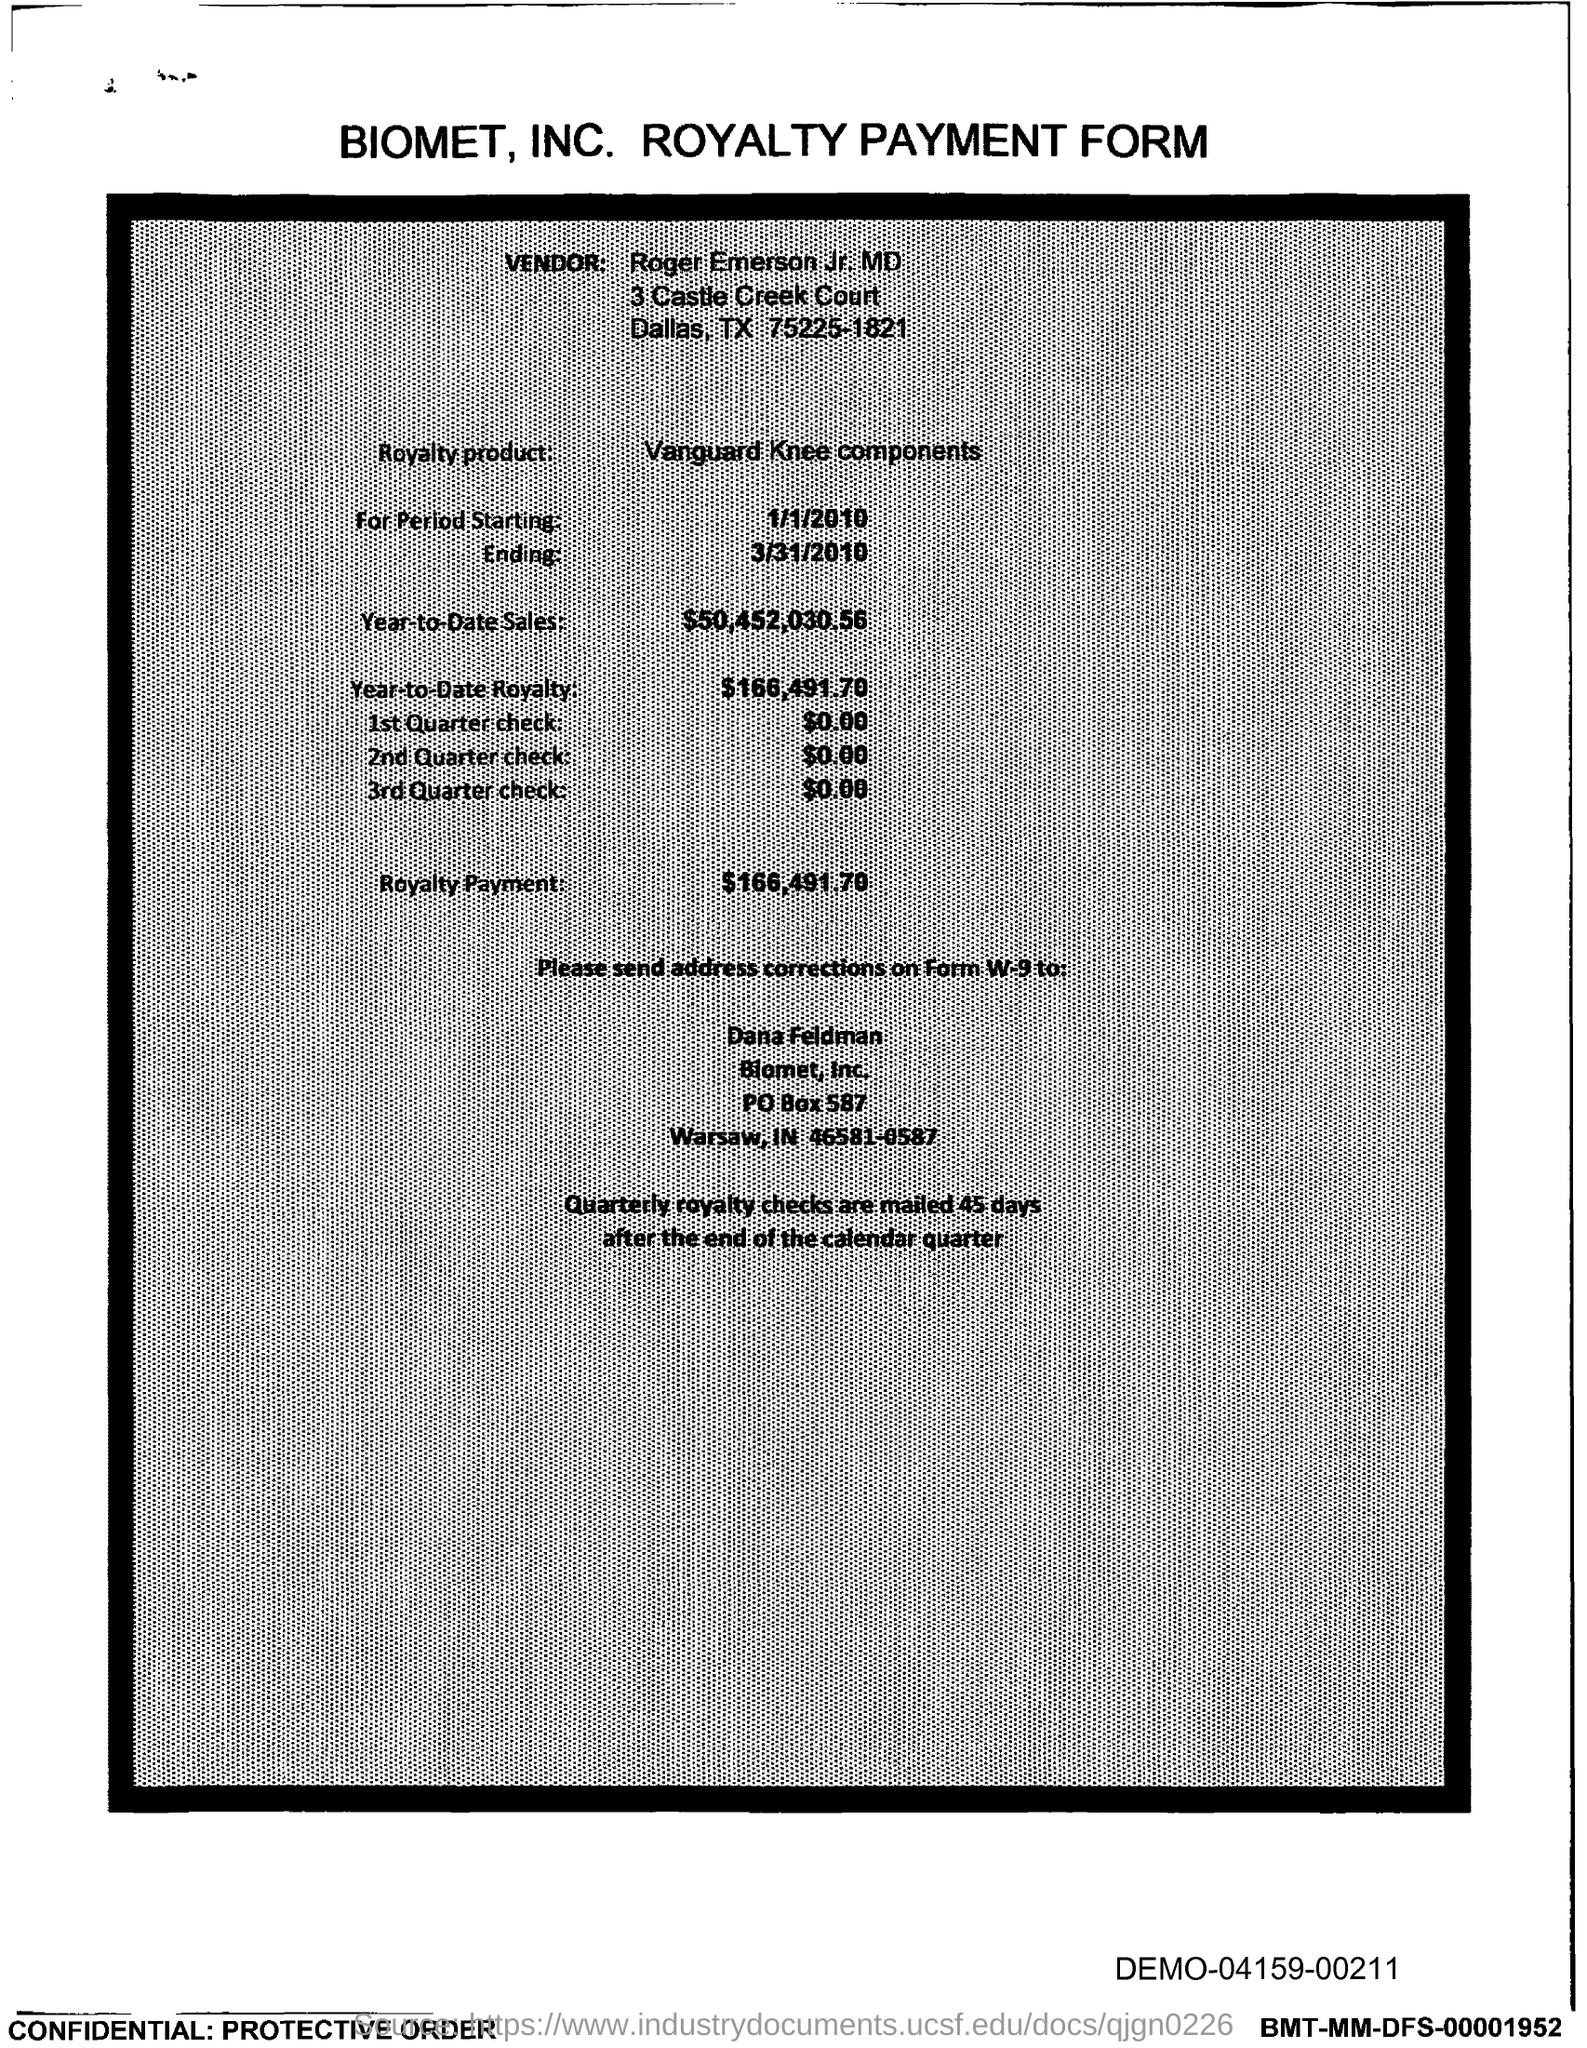Draw attention to some important aspects in this diagram. The royalty product name is Vanguard Knee components. The royalty payment is $166,491.70. The PO box number of Biomet, Inc. is 587. The year-to-date royalty as of today is $166,491.70. The year-to-date sales as of now are $50,452,030.56. 